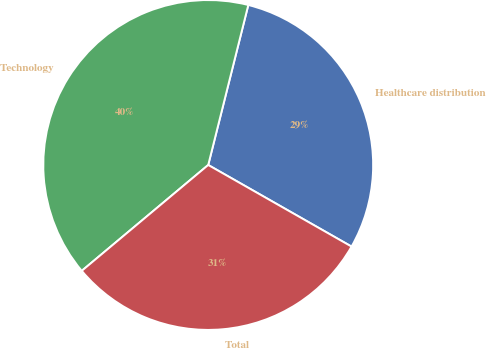Convert chart to OTSL. <chart><loc_0><loc_0><loc_500><loc_500><pie_chart><fcel>Healthcare distribution<fcel>Technology<fcel>Total<nl><fcel>29.33%<fcel>40.0%<fcel>30.67%<nl></chart> 